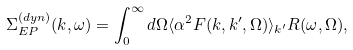Convert formula to latex. <formula><loc_0><loc_0><loc_500><loc_500>\Sigma _ { E P } ^ { ( d y n ) } ( k , \omega ) = \int _ { 0 } ^ { \infty } d \Omega \langle \alpha ^ { 2 } F ( k , k ^ { \prime } , \Omega ) \rangle _ { k ^ { \prime } } R ( \omega , \Omega ) ,</formula> 